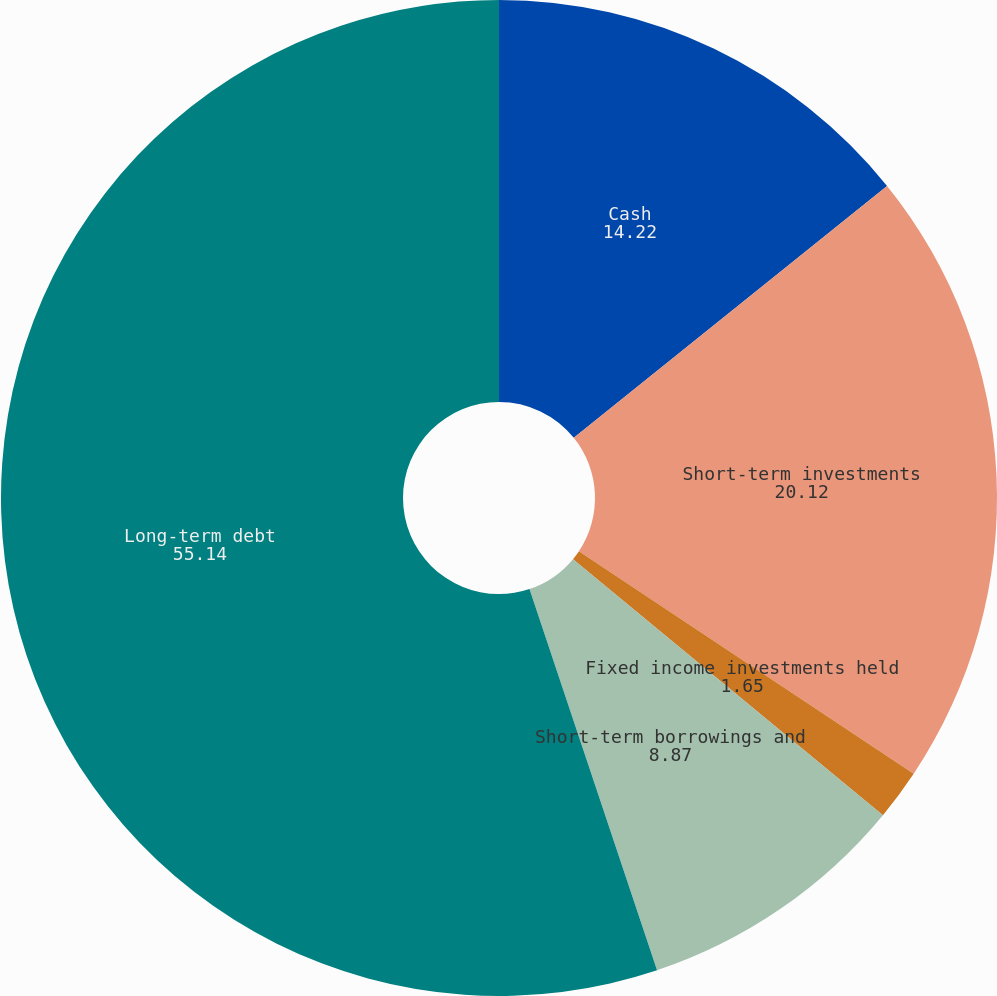<chart> <loc_0><loc_0><loc_500><loc_500><pie_chart><fcel>Cash<fcel>Short-term investments<fcel>Fixed income investments held<fcel>Short-term borrowings and<fcel>Long-term debt<nl><fcel>14.22%<fcel>20.12%<fcel>1.65%<fcel>8.87%<fcel>55.14%<nl></chart> 